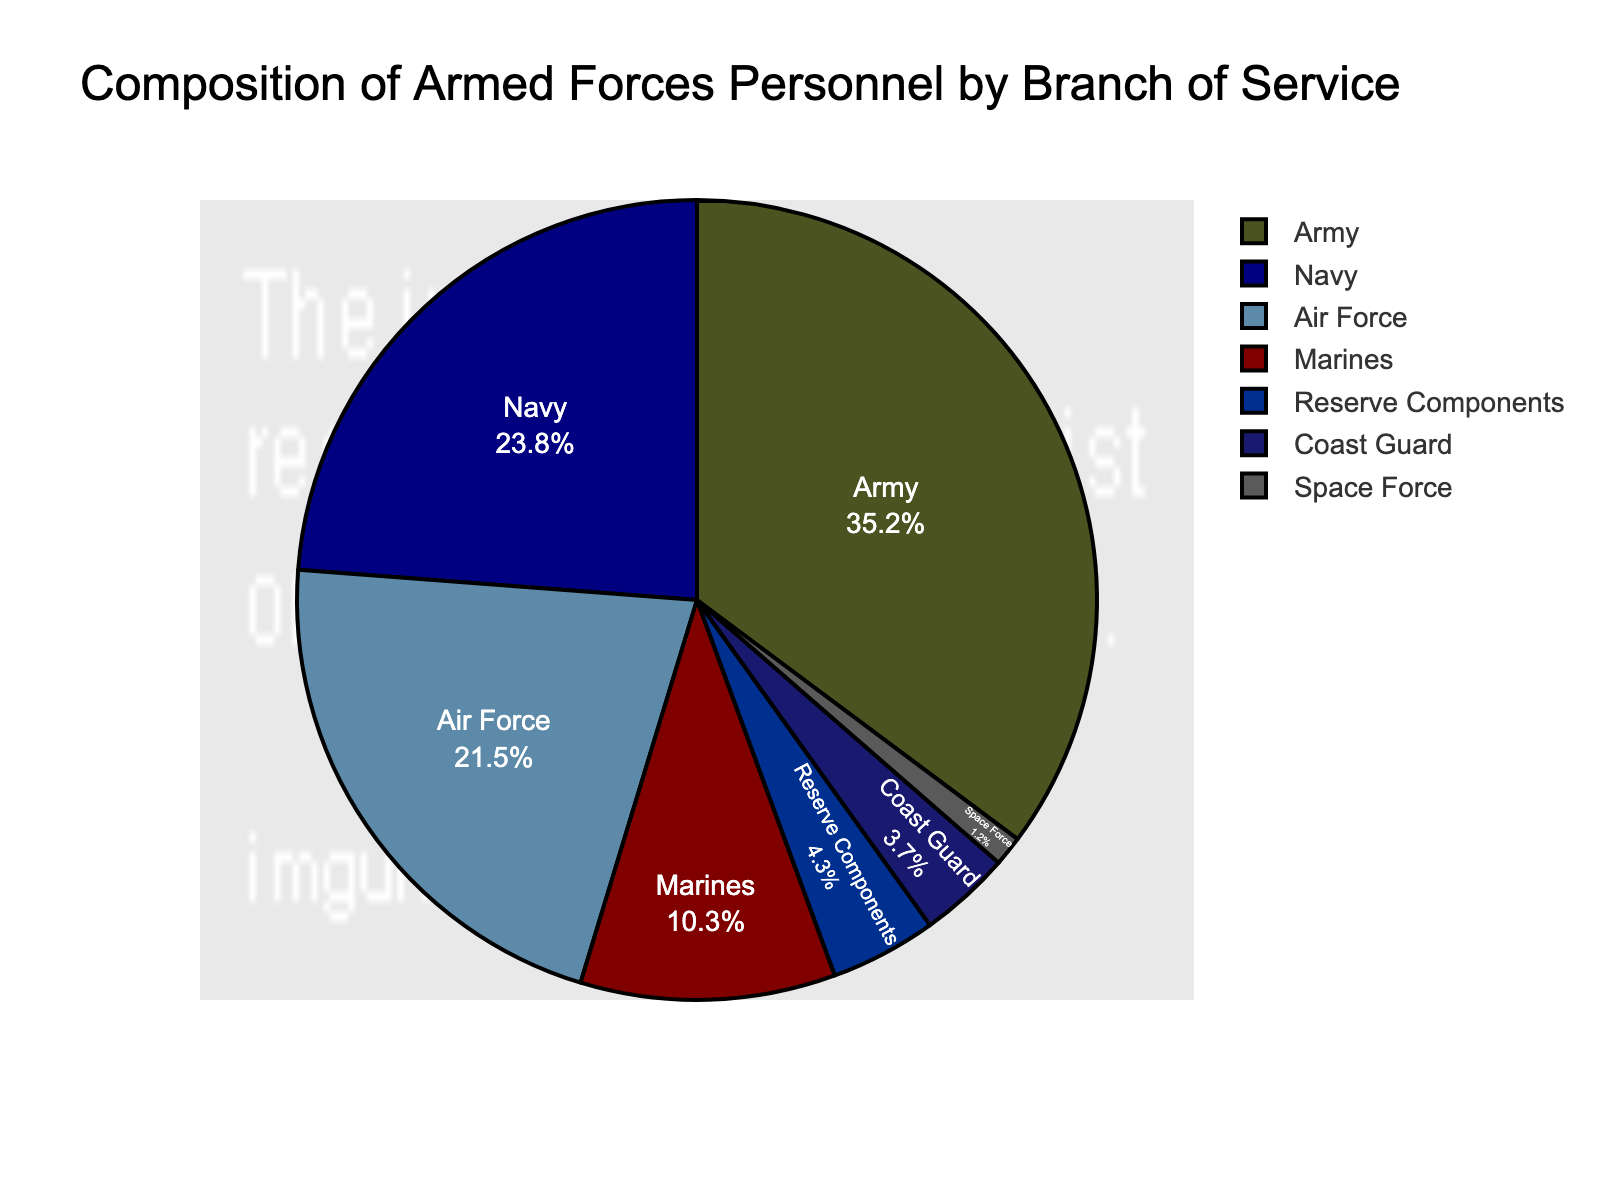What percentage of the armed forces is composed of the Army and the Air Force combined? The Army has 35.2% and the Air Force has 21.5%. Adding these percentages together: 35.2 + 21.5 = 56.7.
Answer: 56.7% Which branch of service has the second-largest percentage of personnel? The largest percentage is the Army with 35.2%. The next largest is the Navy with 23.8%.
Answer: Navy How much larger is the percentage of the Army compared to the Marines? The Army's percentage (35.2%) minus the Marines' percentage (10.3%) is calculated as 35.2 - 10.3 = 24.9.
Answer: 24.9% What is the total percentage of personnel in the Navy and Reserve Components combined? The Navy percentage is 23.8% and the Reserve Components is 4.3%. Adding these together: 23.8 + 4.3 = 28.1.
Answer: 28.1% Which branch of service has the smallest percentage of personnel? The branch with the smallest percentage on the pie chart is the Space Force at 1.2%.
Answer: Space Force Is the percentage of Army personnel more than half of the total Navy and Air Force combined? The total percentage of Navy and Air Force combined is 23.8 + 21.5 = 45.3%. The Army's percentage is 35.2%, which is not more than half (22.65%) of 45.3%.
Answer: No What is the difference in the percentage of personnel between the Coast Guard and Marines? The Marines' percentage (10.3%) minus the Coast Guard's percentage (3.7%) is 10.3 - 3.7 = 6.6.
Answer: 6.6% Which branches combined make up exactly 10% or more of the total personnel? The branches that make up more than 10% are Army (35.2%), Navy (23.8%), and Air Force (21.5%).
Answer: Army, Navy, Air Force What is the average percentage of personnel in the Marines, Coast Guard, and Space Force? Summing their percentages: 10.3 (Marines) + 3.7 (Coast Guard) + 1.2 (Space Force) = 15.2. Dividing by the number of branches (3): 15.2/3 ≈ 5.07.
Answer: 5.07% How does the percentage of Air Force personnel compare visually to the percentage of Navy personnel? On the pie chart, the Air Force segment is slightly smaller than the Navy segment, which indicates a smaller percentage for the Air Force (21.5%) compared to the Navy (23.8%).
Answer: Smaller 